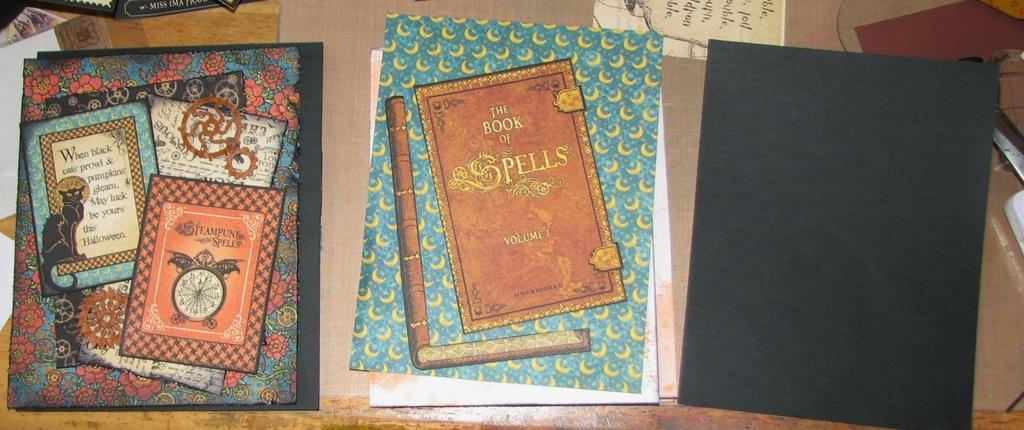Provide a one-sentence caption for the provided image. A book with the text, A book of Spells, lays on a desk. 